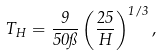Convert formula to latex. <formula><loc_0><loc_0><loc_500><loc_500>T _ { H } = \frac { 9 } { 5 0 \pi } \left ( \frac { 2 5 } { H } \right ) ^ { 1 / 3 } ,</formula> 